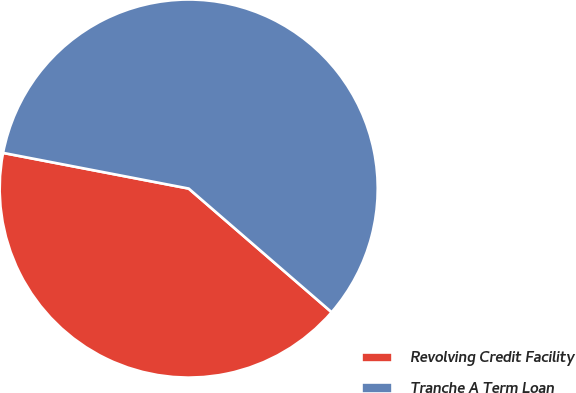Convert chart. <chart><loc_0><loc_0><loc_500><loc_500><pie_chart><fcel>Revolving Credit Facility<fcel>Tranche A Term Loan<nl><fcel>41.67%<fcel>58.33%<nl></chart> 